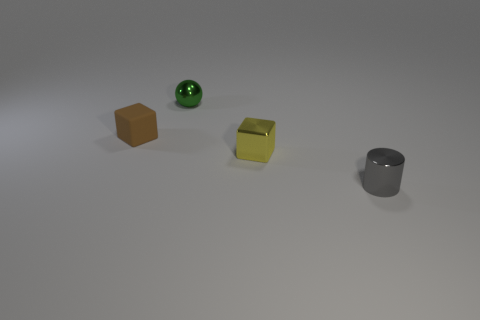Do the cylinder and the tiny rubber object have the same color?
Provide a short and direct response. No. There is a metallic thing that is both behind the small metallic cylinder and in front of the brown object; what is its size?
Offer a very short reply. Small. What number of cylinders are the same size as the matte object?
Offer a terse response. 1. What number of small yellow metal things are in front of the tiny cube that is behind the small yellow metal cube?
Ensure brevity in your answer.  1. There is a small block that is to the right of the sphere; is its color the same as the metallic sphere?
Keep it short and to the point. No. There is a tiny brown block behind the cube that is right of the green ball; are there any tiny metal objects behind it?
Your answer should be very brief. Yes. There is a object that is both right of the tiny brown matte cube and on the left side of the small yellow cube; what is its shape?
Provide a short and direct response. Sphere. Are there any tiny metal cubes of the same color as the small sphere?
Your answer should be very brief. No. The object to the left of the metal thing on the left side of the shiny cube is what color?
Give a very brief answer. Brown. How big is the shiny thing that is behind the tiny thing on the left side of the small object behind the brown cube?
Ensure brevity in your answer.  Small. 